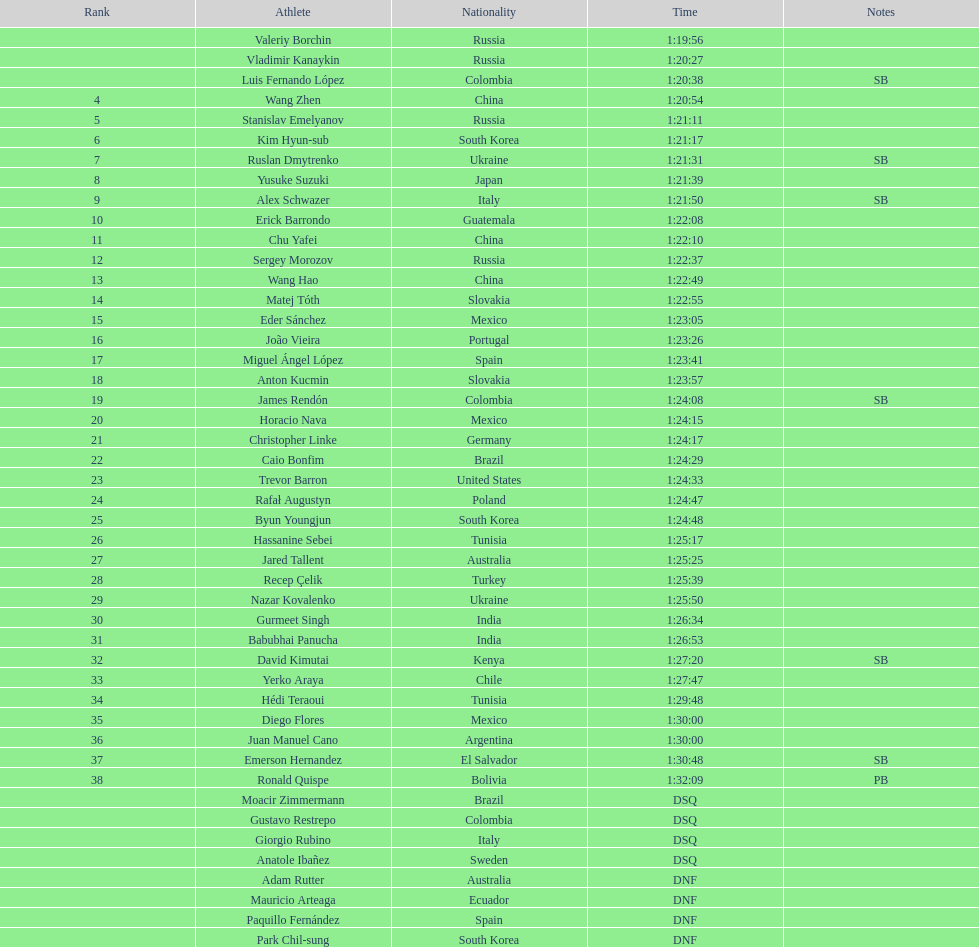Which competitor is the only american to hold a ranking in the 20km? Trevor Barron. 